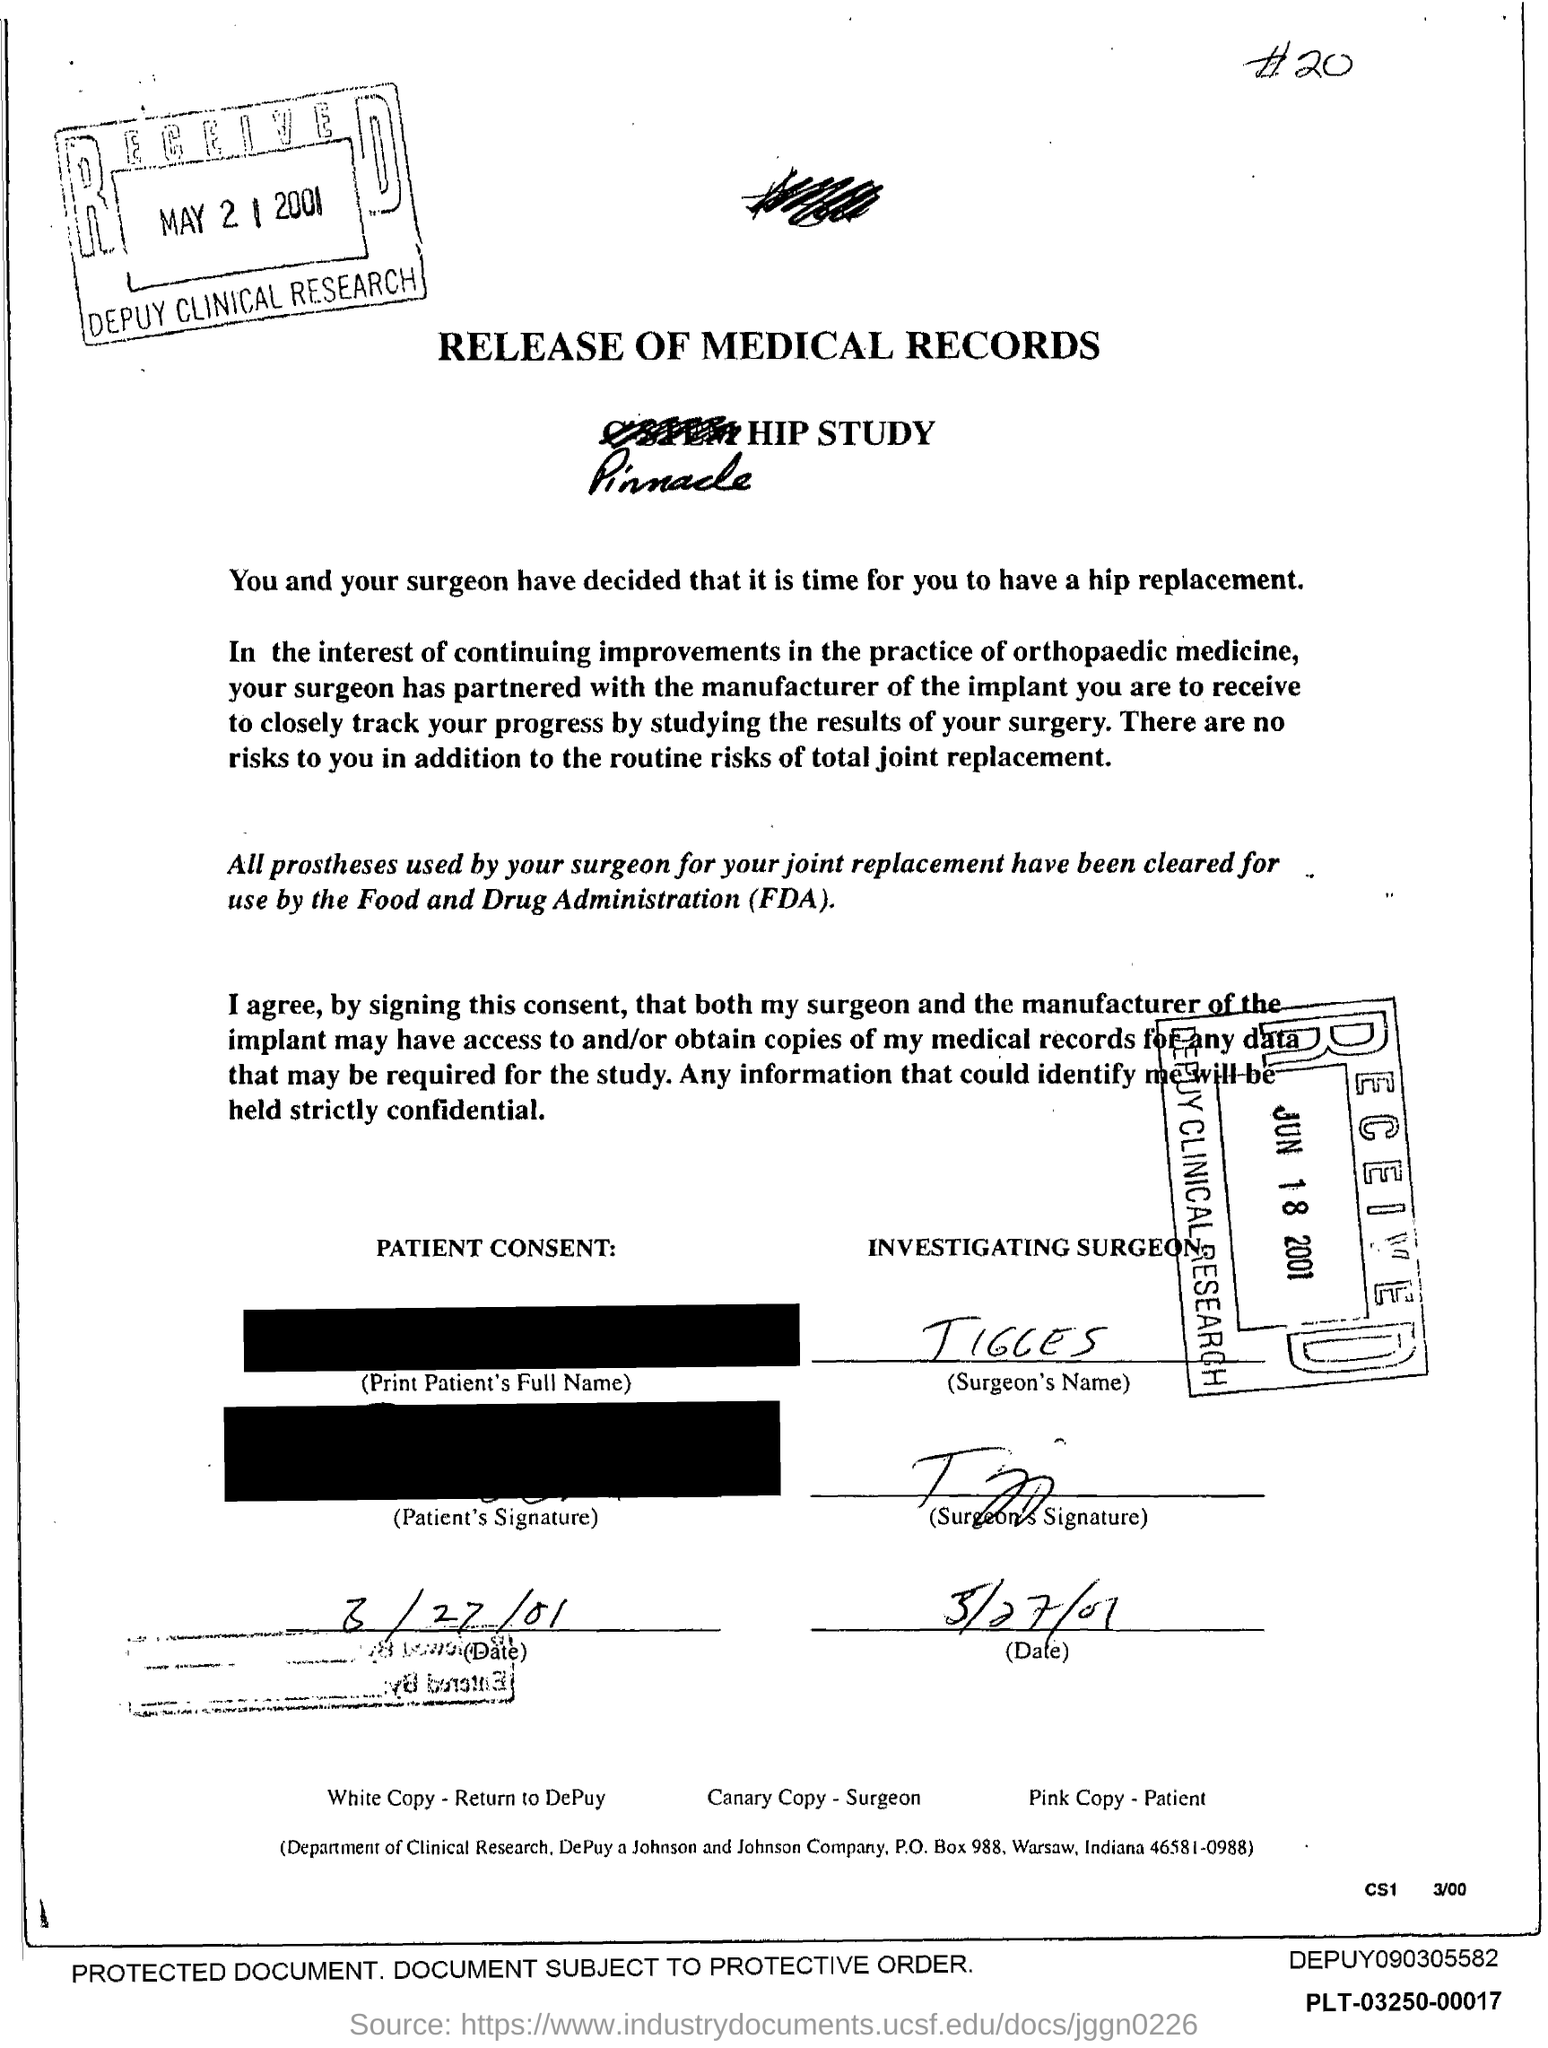Specify some key components in this picture. The investigating surgeon's name is Tigges. The release of medical records is the title of the document. 